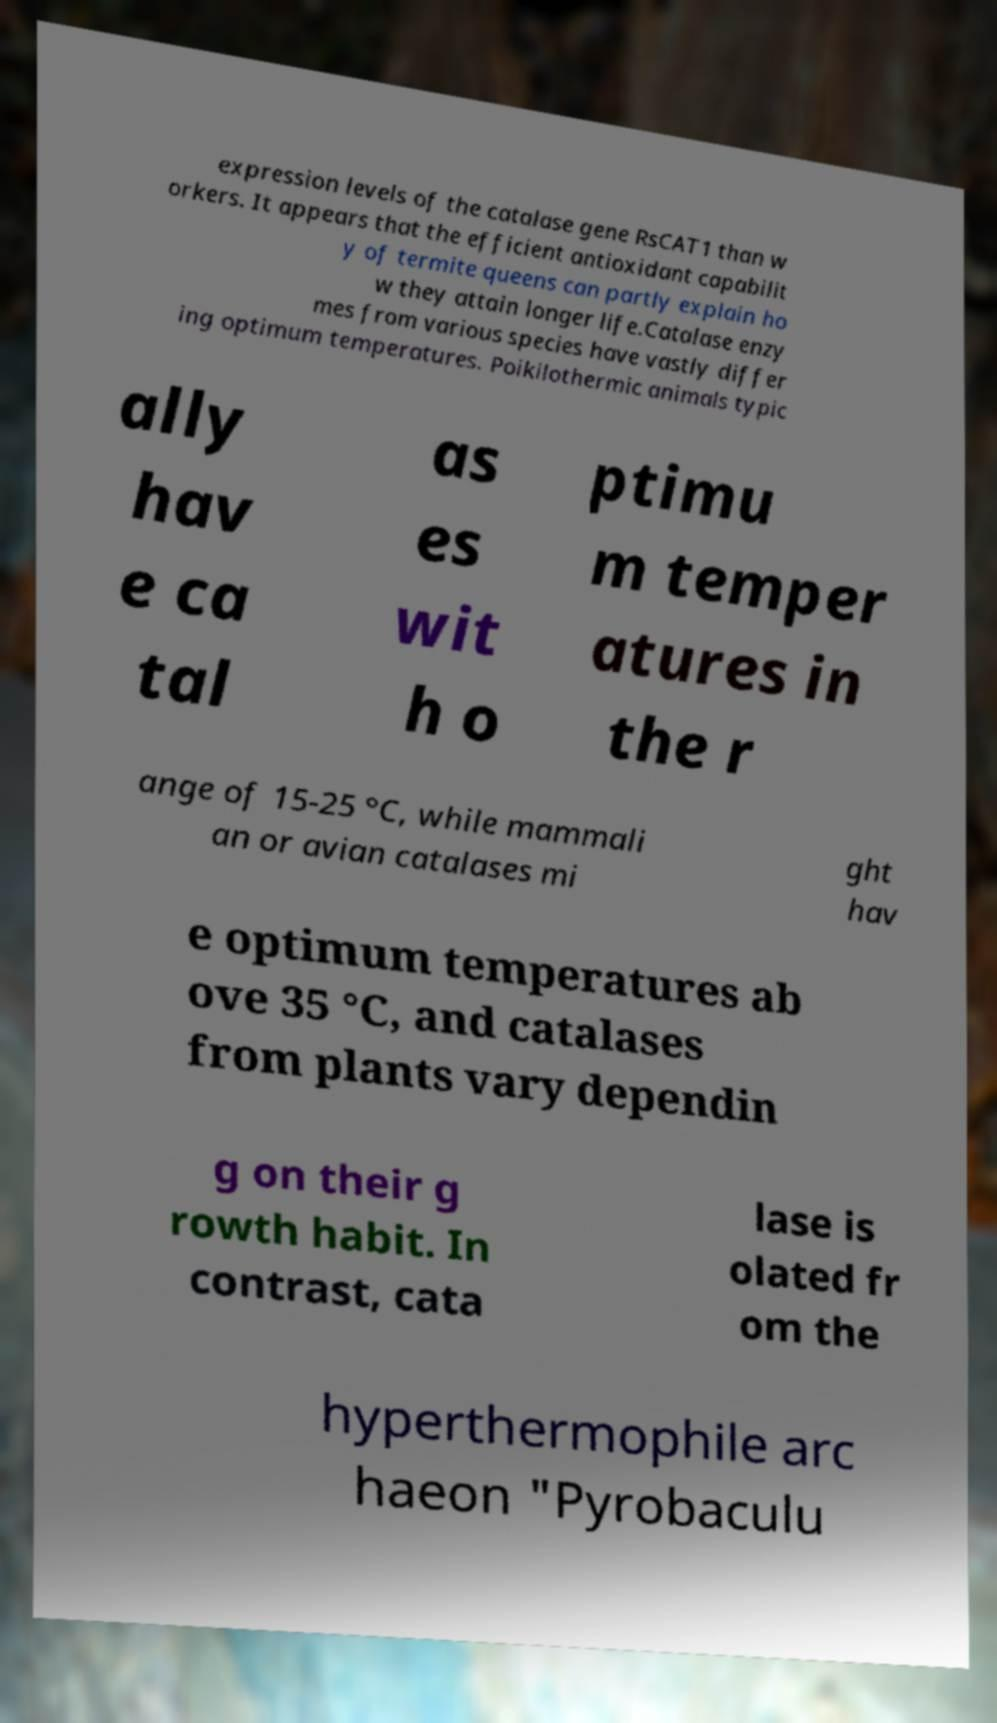There's text embedded in this image that I need extracted. Can you transcribe it verbatim? expression levels of the catalase gene RsCAT1 than w orkers. It appears that the efficient antioxidant capabilit y of termite queens can partly explain ho w they attain longer life.Catalase enzy mes from various species have vastly differ ing optimum temperatures. Poikilothermic animals typic ally hav e ca tal as es wit h o ptimu m temper atures in the r ange of 15-25 °C, while mammali an or avian catalases mi ght hav e optimum temperatures ab ove 35 °C, and catalases from plants vary dependin g on their g rowth habit. In contrast, cata lase is olated fr om the hyperthermophile arc haeon "Pyrobaculu 